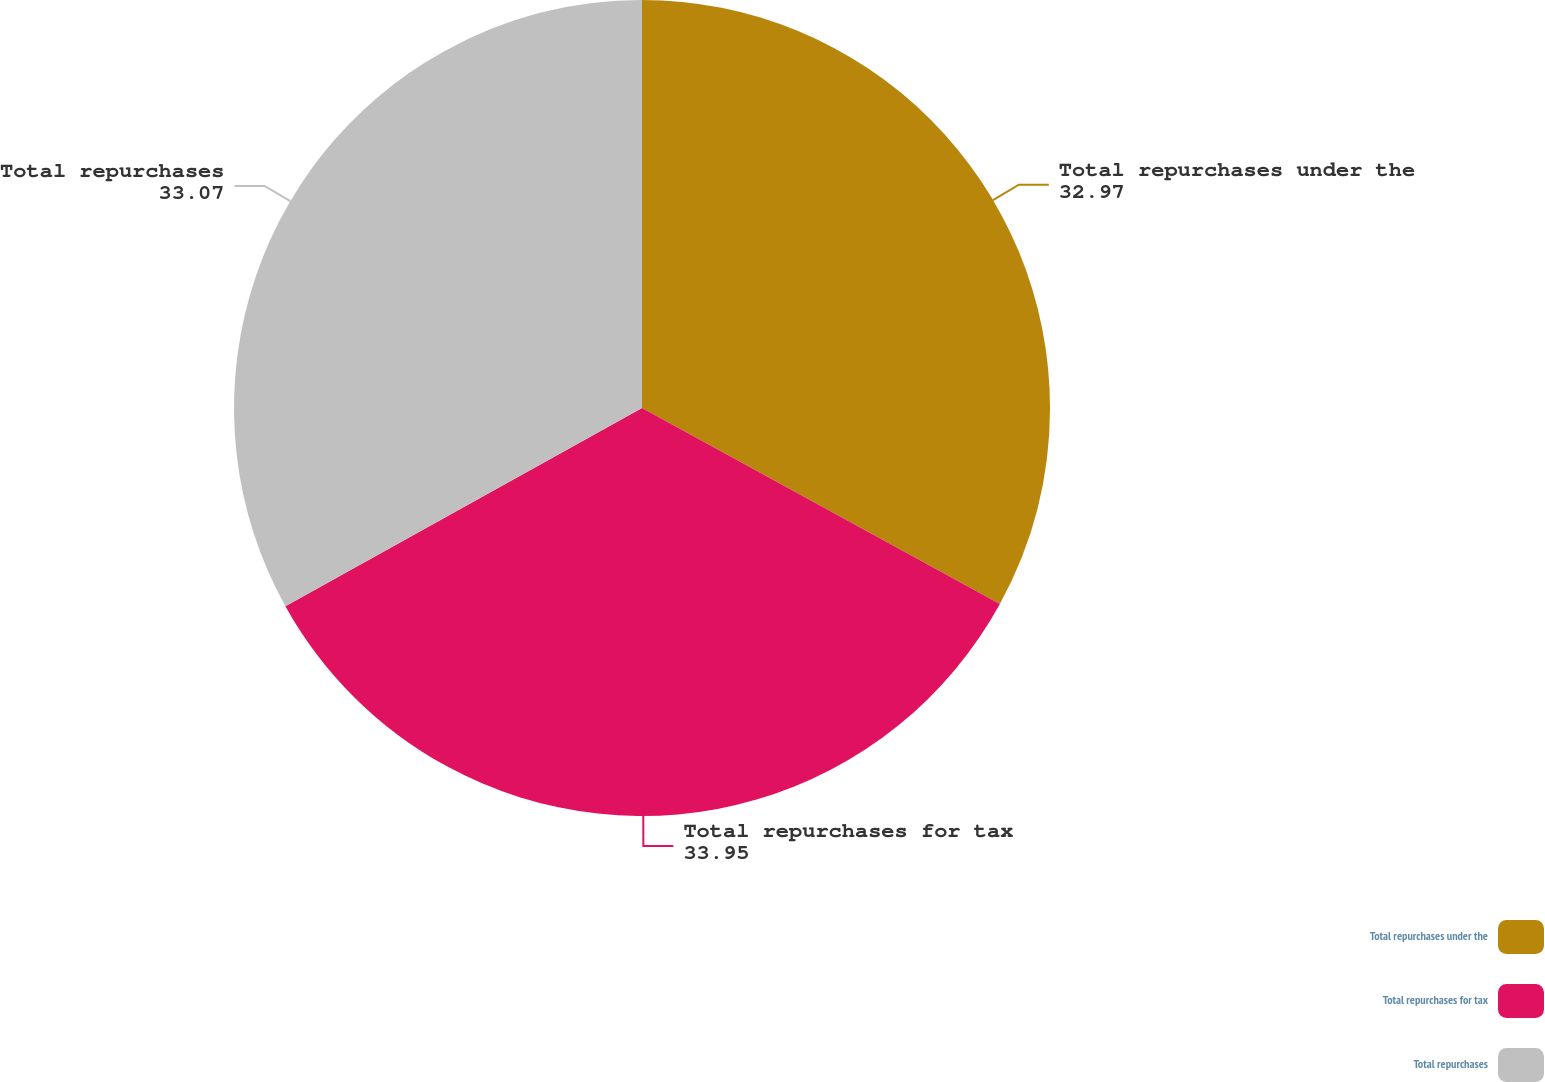Convert chart to OTSL. <chart><loc_0><loc_0><loc_500><loc_500><pie_chart><fcel>Total repurchases under the<fcel>Total repurchases for tax<fcel>Total repurchases<nl><fcel>32.97%<fcel>33.95%<fcel>33.07%<nl></chart> 